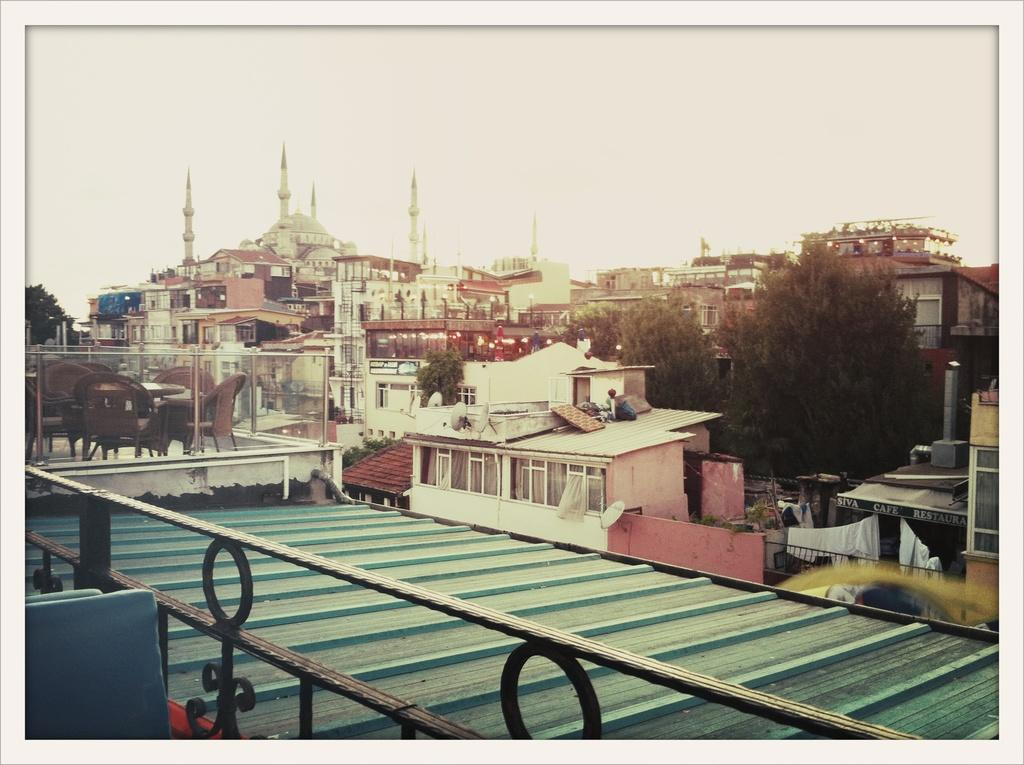What type of structure can be seen in the image? There is a railing, chairs, and a table in the image. What else is visible in the image besides the furniture? The roof of a building, trees, and other buildings are visible in the image. What can be seen in the background of the image? The sky is visible in the background of the image. What type of weather can be seen in the image? The provided facts do not mention any specific weather conditions, so we cannot determine the weather from the image. How many passengers are sitting on the chairs in the image? There is no information about passengers in the image; it only shows chairs and other objects. 